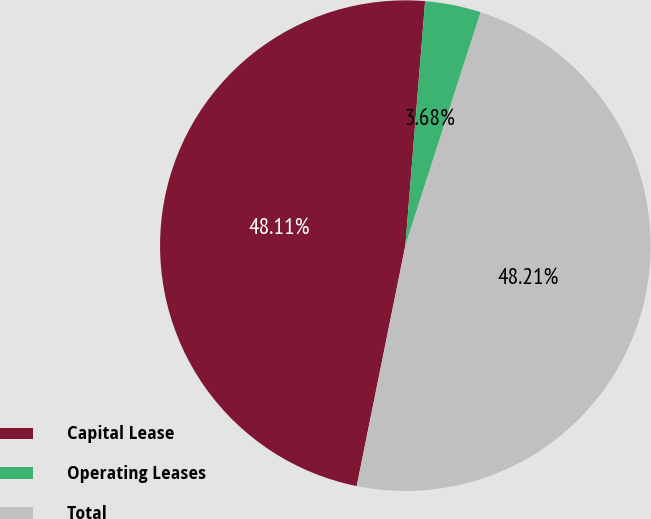Convert chart to OTSL. <chart><loc_0><loc_0><loc_500><loc_500><pie_chart><fcel>Capital Lease<fcel>Operating Leases<fcel>Total<nl><fcel>48.11%<fcel>3.68%<fcel>48.21%<nl></chart> 